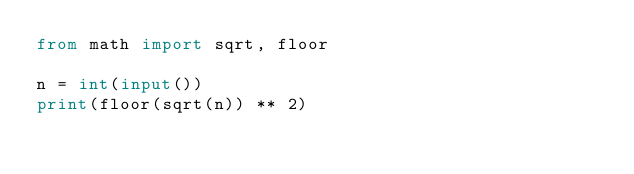<code> <loc_0><loc_0><loc_500><loc_500><_Python_>from math import sqrt, floor

n = int(input())
print(floor(sqrt(n)) ** 2)</code> 